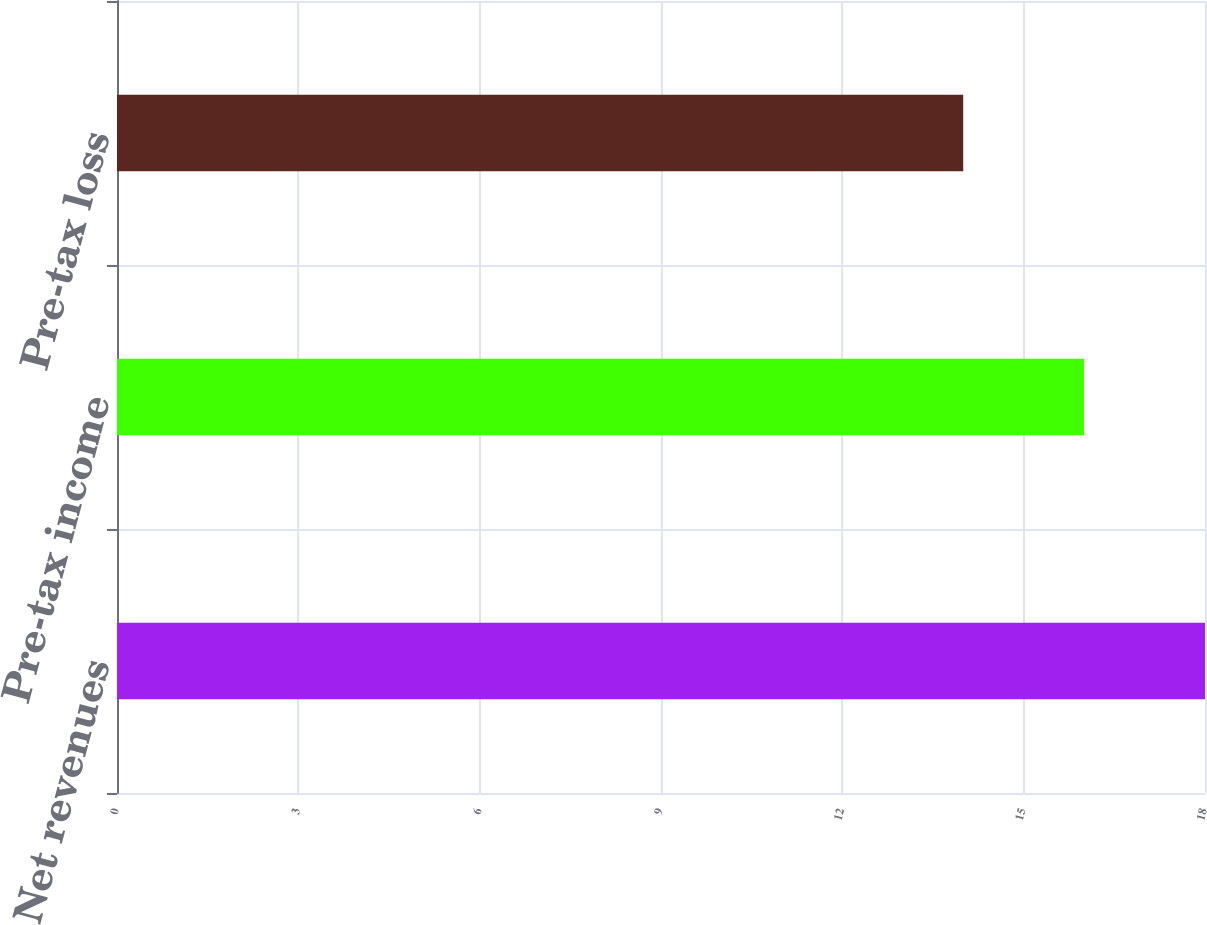<chart> <loc_0><loc_0><loc_500><loc_500><bar_chart><fcel>Net revenues<fcel>Pre-tax income<fcel>Pre-tax loss<nl><fcel>18<fcel>16<fcel>14<nl></chart> 